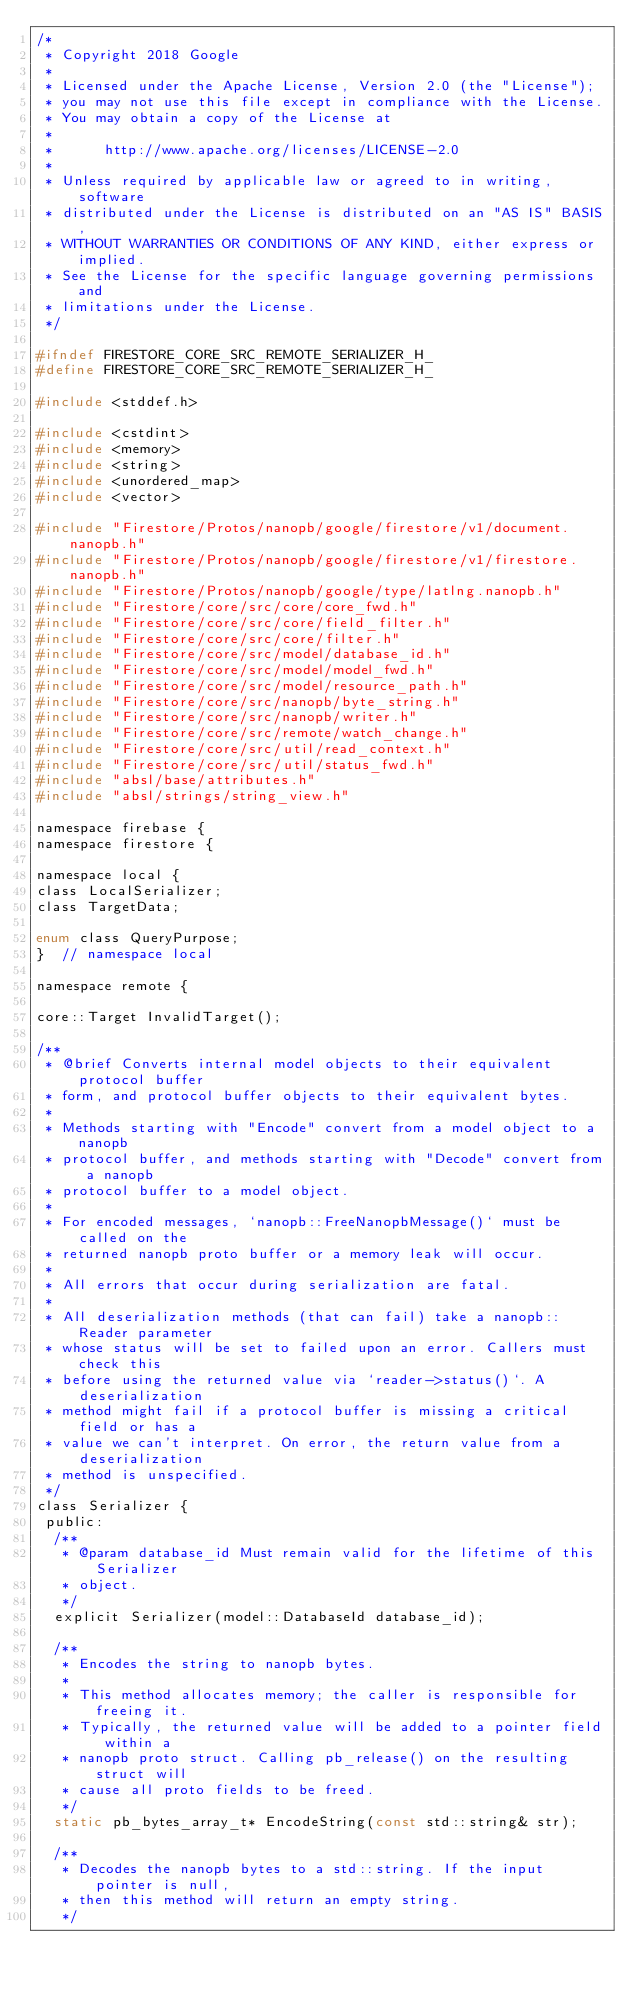Convert code to text. <code><loc_0><loc_0><loc_500><loc_500><_C_>/*
 * Copyright 2018 Google
 *
 * Licensed under the Apache License, Version 2.0 (the "License");
 * you may not use this file except in compliance with the License.
 * You may obtain a copy of the License at
 *
 *      http://www.apache.org/licenses/LICENSE-2.0
 *
 * Unless required by applicable law or agreed to in writing, software
 * distributed under the License is distributed on an "AS IS" BASIS,
 * WITHOUT WARRANTIES OR CONDITIONS OF ANY KIND, either express or implied.
 * See the License for the specific language governing permissions and
 * limitations under the License.
 */

#ifndef FIRESTORE_CORE_SRC_REMOTE_SERIALIZER_H_
#define FIRESTORE_CORE_SRC_REMOTE_SERIALIZER_H_

#include <stddef.h>

#include <cstdint>
#include <memory>
#include <string>
#include <unordered_map>
#include <vector>

#include "Firestore/Protos/nanopb/google/firestore/v1/document.nanopb.h"
#include "Firestore/Protos/nanopb/google/firestore/v1/firestore.nanopb.h"
#include "Firestore/Protos/nanopb/google/type/latlng.nanopb.h"
#include "Firestore/core/src/core/core_fwd.h"
#include "Firestore/core/src/core/field_filter.h"
#include "Firestore/core/src/core/filter.h"
#include "Firestore/core/src/model/database_id.h"
#include "Firestore/core/src/model/model_fwd.h"
#include "Firestore/core/src/model/resource_path.h"
#include "Firestore/core/src/nanopb/byte_string.h"
#include "Firestore/core/src/nanopb/writer.h"
#include "Firestore/core/src/remote/watch_change.h"
#include "Firestore/core/src/util/read_context.h"
#include "Firestore/core/src/util/status_fwd.h"
#include "absl/base/attributes.h"
#include "absl/strings/string_view.h"

namespace firebase {
namespace firestore {

namespace local {
class LocalSerializer;
class TargetData;

enum class QueryPurpose;
}  // namespace local

namespace remote {

core::Target InvalidTarget();

/**
 * @brief Converts internal model objects to their equivalent protocol buffer
 * form, and protocol buffer objects to their equivalent bytes.
 *
 * Methods starting with "Encode" convert from a model object to a nanopb
 * protocol buffer, and methods starting with "Decode" convert from a nanopb
 * protocol buffer to a model object.
 *
 * For encoded messages, `nanopb::FreeNanopbMessage()` must be called on the
 * returned nanopb proto buffer or a memory leak will occur.
 *
 * All errors that occur during serialization are fatal.
 *
 * All deserialization methods (that can fail) take a nanopb::Reader parameter
 * whose status will be set to failed upon an error. Callers must check this
 * before using the returned value via `reader->status()`. A deserialization
 * method might fail if a protocol buffer is missing a critical field or has a
 * value we can't interpret. On error, the return value from a deserialization
 * method is unspecified.
 */
class Serializer {
 public:
  /**
   * @param database_id Must remain valid for the lifetime of this Serializer
   * object.
   */
  explicit Serializer(model::DatabaseId database_id);

  /**
   * Encodes the string to nanopb bytes.
   *
   * This method allocates memory; the caller is responsible for freeing it.
   * Typically, the returned value will be added to a pointer field within a
   * nanopb proto struct. Calling pb_release() on the resulting struct will
   * cause all proto fields to be freed.
   */
  static pb_bytes_array_t* EncodeString(const std::string& str);

  /**
   * Decodes the nanopb bytes to a std::string. If the input pointer is null,
   * then this method will return an empty string.
   */</code> 